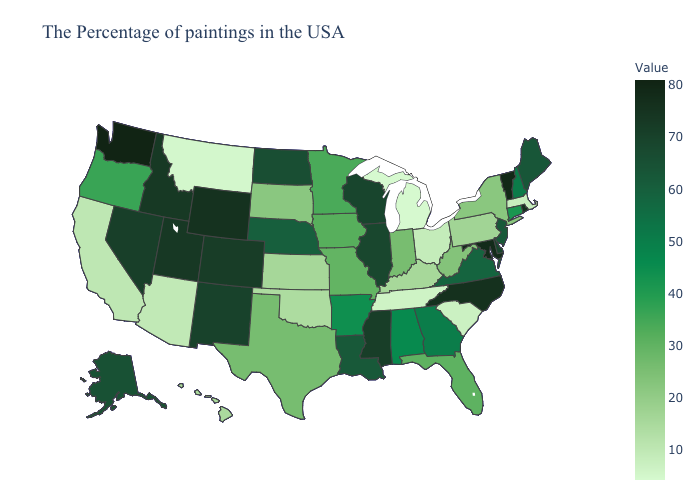Among the states that border New Hampshire , which have the lowest value?
Quick response, please. Massachusetts. Does California have a higher value than New Jersey?
Answer briefly. No. Does Kentucky have the lowest value in the USA?
Keep it brief. No. Does New Mexico have a lower value than Washington?
Be succinct. Yes. Which states hav the highest value in the West?
Keep it brief. Washington. Does Michigan have the lowest value in the USA?
Short answer required. Yes. 